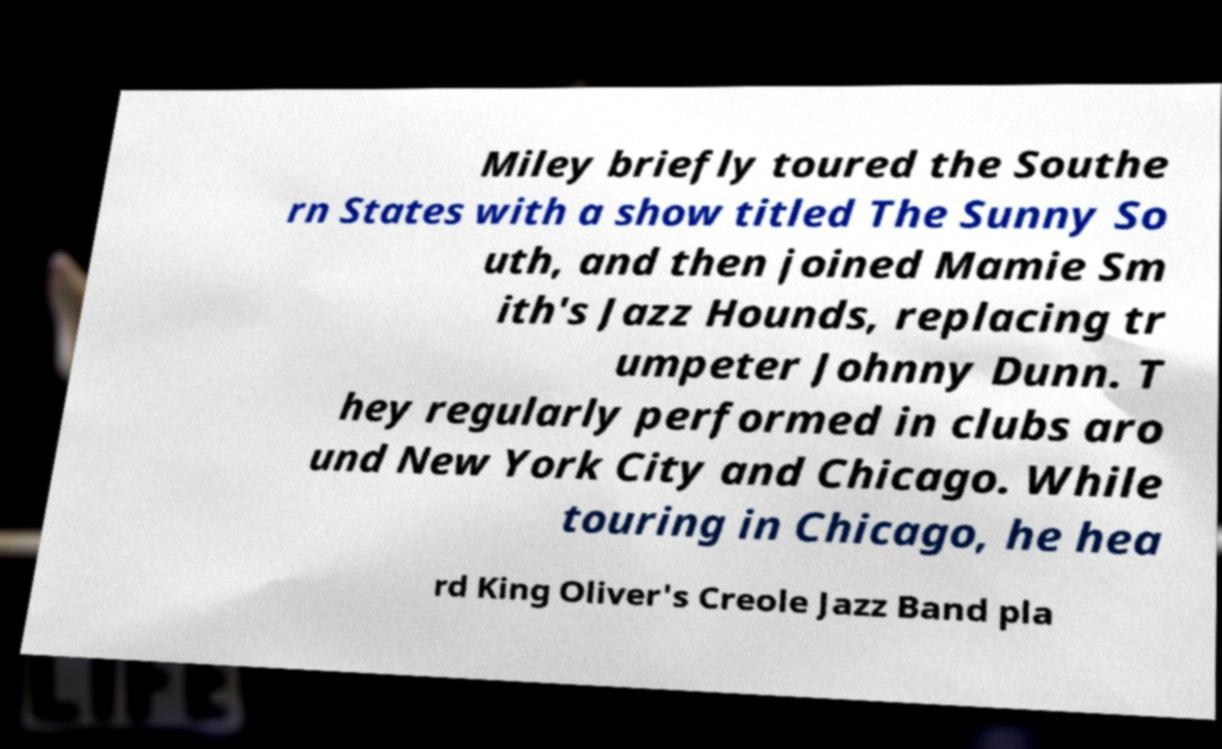Please identify and transcribe the text found in this image. Miley briefly toured the Southe rn States with a show titled The Sunny So uth, and then joined Mamie Sm ith's Jazz Hounds, replacing tr umpeter Johnny Dunn. T hey regularly performed in clubs aro und New York City and Chicago. While touring in Chicago, he hea rd King Oliver's Creole Jazz Band pla 